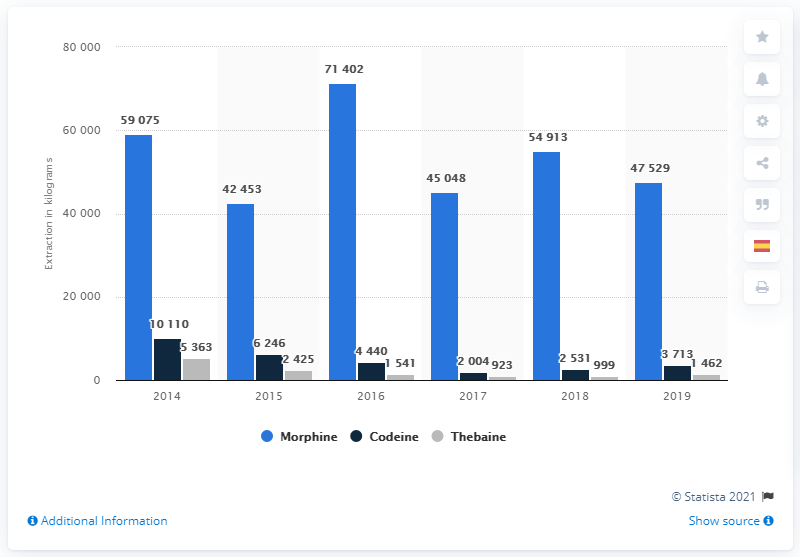Draw attention to some important aspects in this diagram. In 2019, a total of 47,529 metric tons of morphine was extracted worldwide. 